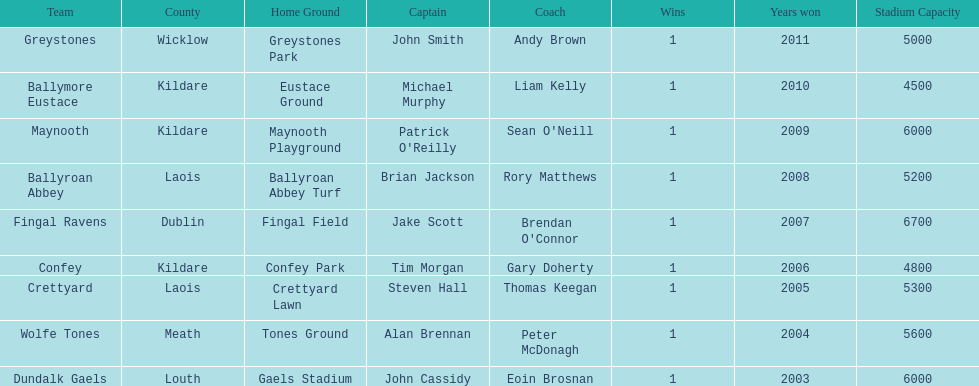Ballymore eustace is from the same county as what team that won in 2009? Maynooth. 